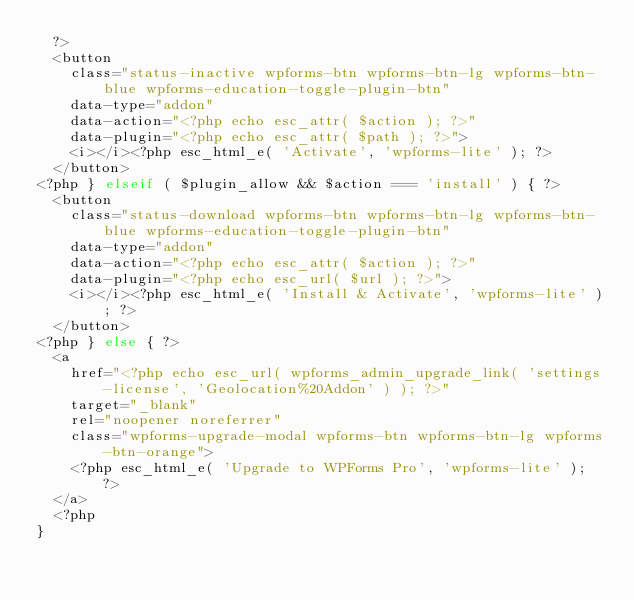Convert code to text. <code><loc_0><loc_0><loc_500><loc_500><_PHP_>	?>
	<button
		class="status-inactive wpforms-btn wpforms-btn-lg wpforms-btn-blue wpforms-education-toggle-plugin-btn"
		data-type="addon"
		data-action="<?php echo esc_attr( $action ); ?>"
		data-plugin="<?php echo esc_attr( $path ); ?>">
		<i></i><?php esc_html_e( 'Activate', 'wpforms-lite' ); ?>
	</button>
<?php } elseif ( $plugin_allow && $action === 'install' ) { ?>
	<button
		class="status-download wpforms-btn wpforms-btn-lg wpforms-btn-blue wpforms-education-toggle-plugin-btn"
		data-type="addon"
		data-action="<?php echo esc_attr( $action ); ?>"
		data-plugin="<?php echo esc_url( $url ); ?>">
		<i></i><?php esc_html_e( 'Install & Activate', 'wpforms-lite' ); ?>
	</button>
<?php } else { ?>
	<a
		href="<?php echo esc_url( wpforms_admin_upgrade_link( 'settings-license', 'Geolocation%20Addon' ) ); ?>"
		target="_blank"
		rel="noopener noreferrer"
		class="wpforms-upgrade-modal wpforms-btn wpforms-btn-lg wpforms-btn-orange">
		<?php esc_html_e( 'Upgrade to WPForms Pro', 'wpforms-lite' ); ?>
	</a>
	<?php
}
</code> 